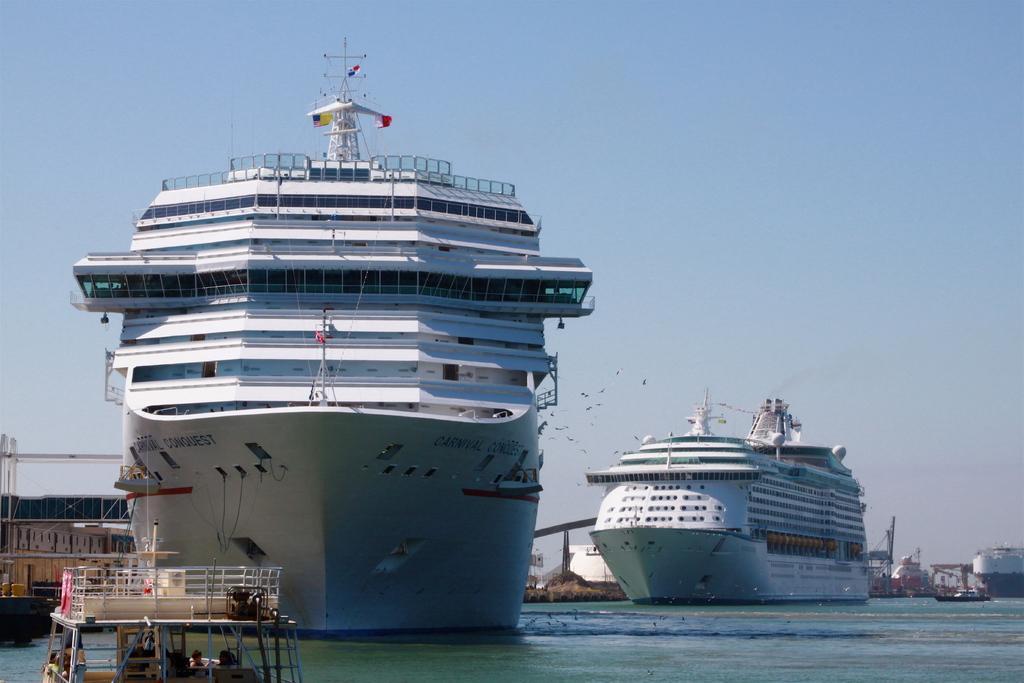How would you summarize this image in a sentence or two? In this image there are ships with flags and there are boats on the water, and in the background there is sky. 